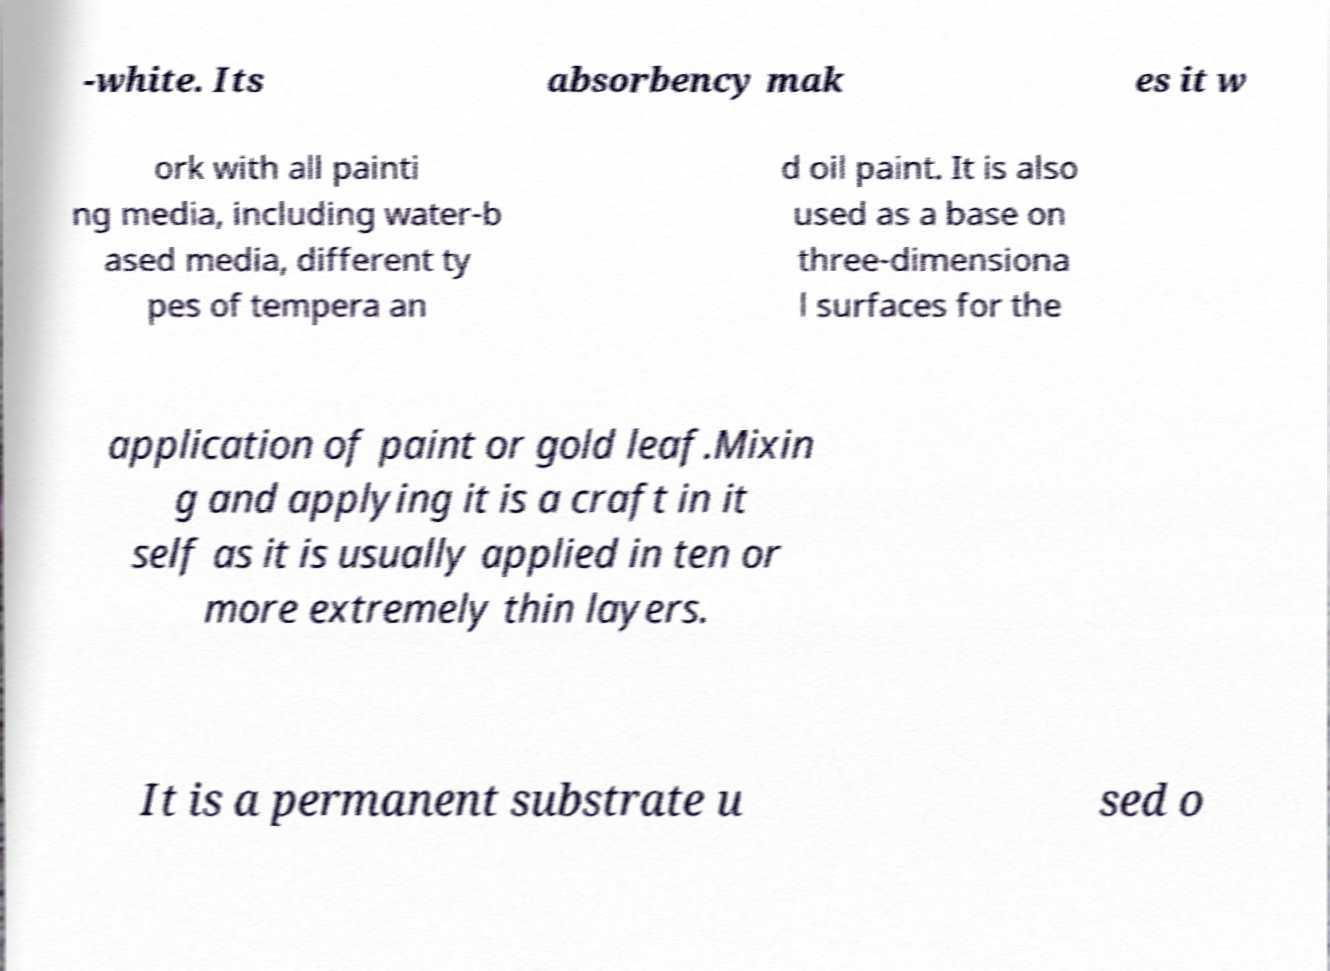Can you accurately transcribe the text from the provided image for me? -white. Its absorbency mak es it w ork with all painti ng media, including water-b ased media, different ty pes of tempera an d oil paint. It is also used as a base on three-dimensiona l surfaces for the application of paint or gold leaf.Mixin g and applying it is a craft in it self as it is usually applied in ten or more extremely thin layers. It is a permanent substrate u sed o 